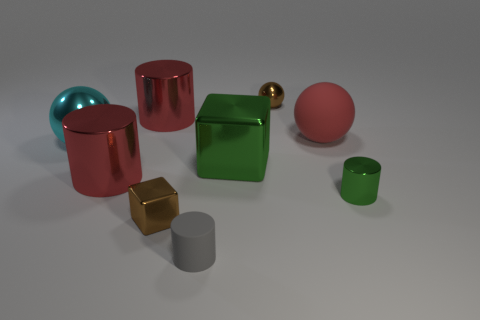What size is the sphere that is the same color as the tiny metal cube?
Offer a very short reply. Small. Do the rubber cylinder and the large metallic block have the same color?
Offer a very short reply. No. Are there any other metallic blocks that have the same color as the tiny cube?
Offer a very short reply. No. There is a rubber cylinder that is the same size as the brown cube; what color is it?
Your answer should be very brief. Gray. Are there any tiny green metal things of the same shape as the gray object?
Keep it short and to the point. Yes. What is the shape of the thing that is the same color as the large block?
Give a very brief answer. Cylinder. Is there a red thing behind the tiny shiny object that is behind the shiny sphere that is in front of the large rubber thing?
Your answer should be very brief. No. What is the shape of the green shiny thing that is the same size as the gray matte cylinder?
Give a very brief answer. Cylinder. There is a big shiny thing that is the same shape as the big red matte object; what is its color?
Your answer should be very brief. Cyan. What number of objects are large cyan balls or small green metal cubes?
Ensure brevity in your answer.  1. 